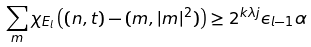Convert formula to latex. <formula><loc_0><loc_0><loc_500><loc_500>\sum _ { m } \chi _ { E _ { l } } \left ( ( n , t ) - ( m , | m | ^ { 2 } ) \right ) \geq 2 ^ { k \lambda j } \epsilon _ { l - 1 } \alpha</formula> 